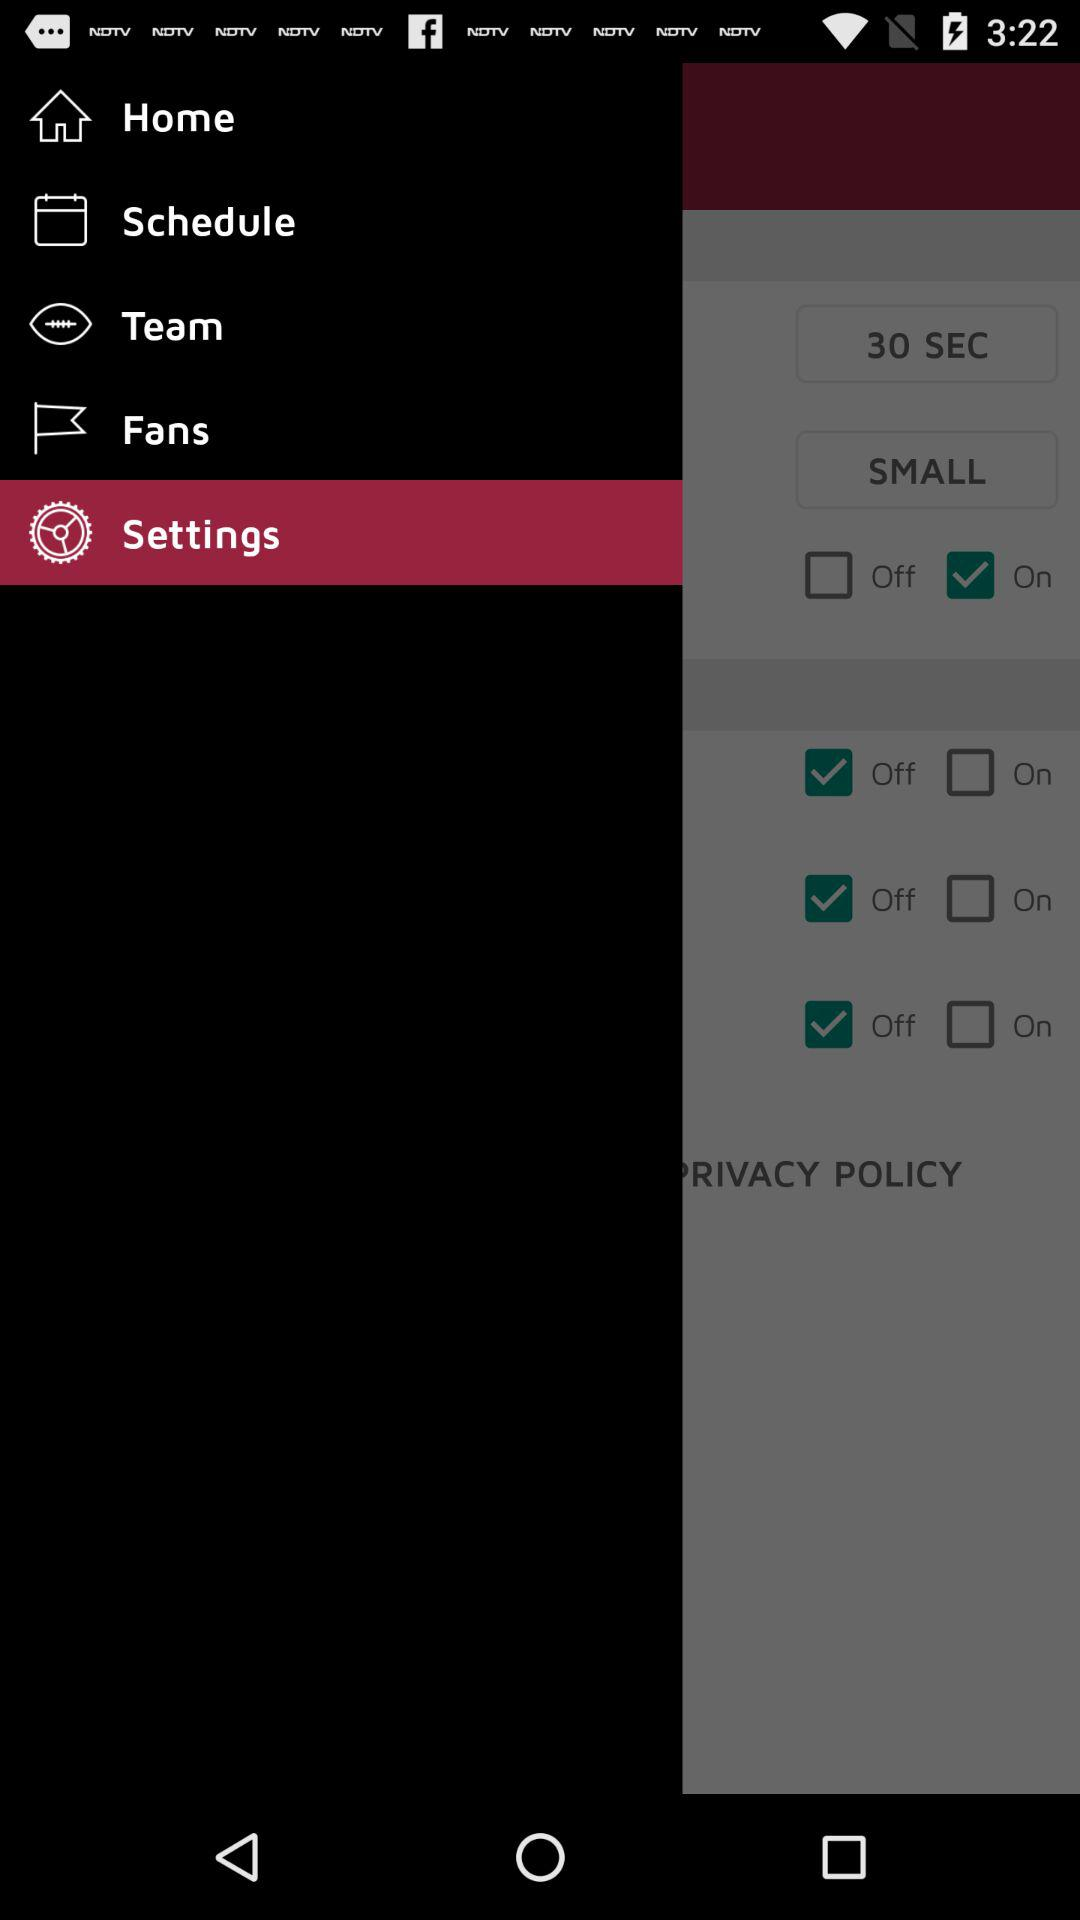Which item has been selected? The item that has been selected is "Settings". 